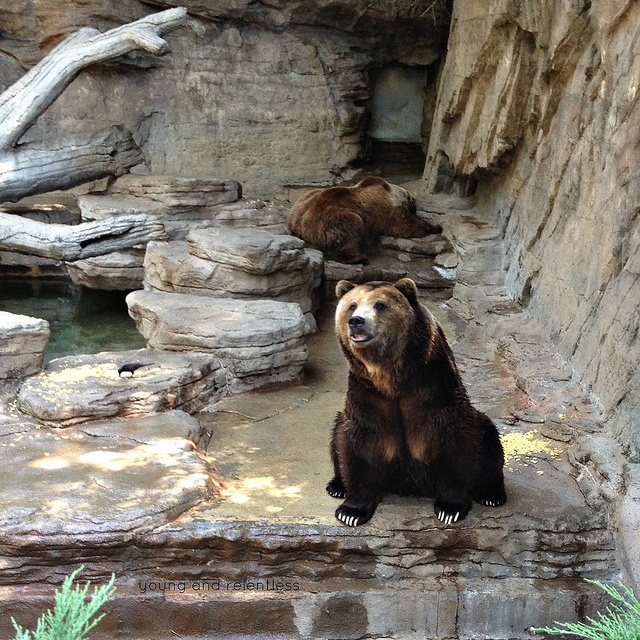Describe the objects in this image and their specific colors. I can see bear in gray, black, and maroon tones and bear in gray, black, and maroon tones in this image. 